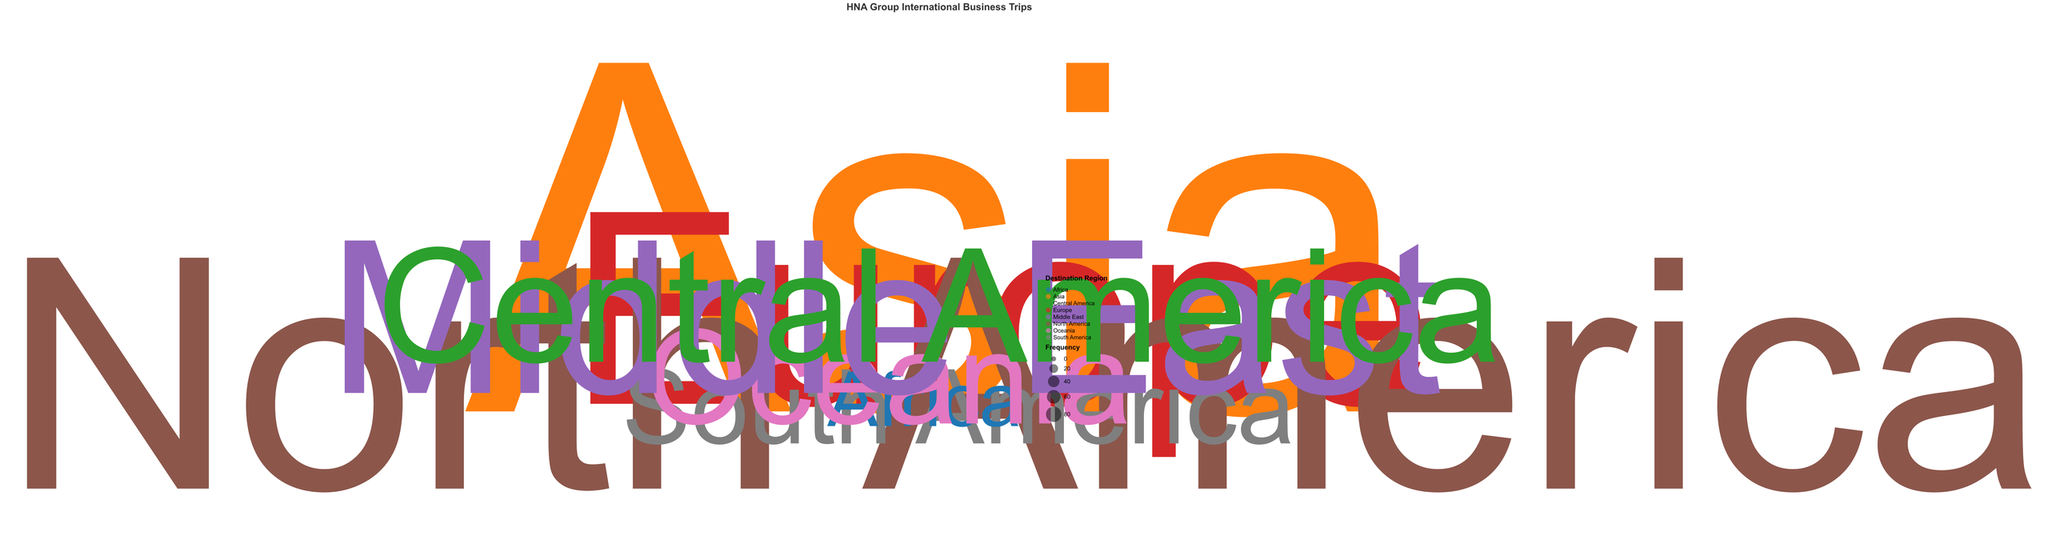What is the title of the figure? The title of the figure is usually located at the top. In this case, it reads "HNA Group International Business Trips."
Answer: HNA Group International Business Trips Which destination region has the highest frequency of trips? Identify the data point with the largest radius or size on the plot. Here, it is Asia with a frequency of 80.
Answer: Asia How many destination regions are represented in the chart? Count the number of distinct data points or color-coded categories in the plot. There are 8 destination regions displayed.
Answer: 8 What is the frequency of trips to Europe? Locate the point labeled "Europe" and read the corresponding frequency value. The frequency of trips to Europe is 40.
Answer: 40 Which destination region has the lowest frequency of trips, and what is its frequency? Identify the smallest data point by radius or size. The point for Africa has the lowest frequency of 5.
Answer: Africa, 5 How does the frequency of trips to North America compare to that of Central America? Locate the data points for North America and Central America, and compare their frequencies. North America has a frequency of 50, whereas Central America has a frequency of 20.
Answer: North America has a higher frequency What is the total frequency of trips made to destinations in Asia, Europe, and North America combined? Sum the frequencies for Asia (80), Europe (40), and North America (50). The combined frequency is 170.
Answer: 170 What is the median frequency of trips across all destination regions? Organize all frequencies in numerical order: 5, 10, 15, 20, 30, 40, 50, 80. The median, being the middle value in a sorted list, is the average of the 4th (20) and 5th (30) values: (20+30)/2 = 25.
Answer: 25 Which destination region is positioned at an angle of 270 degrees, and what is its frequency? Identify the data point at the angle of 270 degrees. It is the Middle East with a frequency of 30.
Answer: Middle East, 30 Describe the general pattern of trip frequencies across the regions. Observe the size and radius of points; most trips are concentrated in Asia, Europe, and North America (high frequencies). Other regions have significantly fewer trips.
Answer: Most trips are made to Asia, Europe, and North America, while other regions have fewer trips 